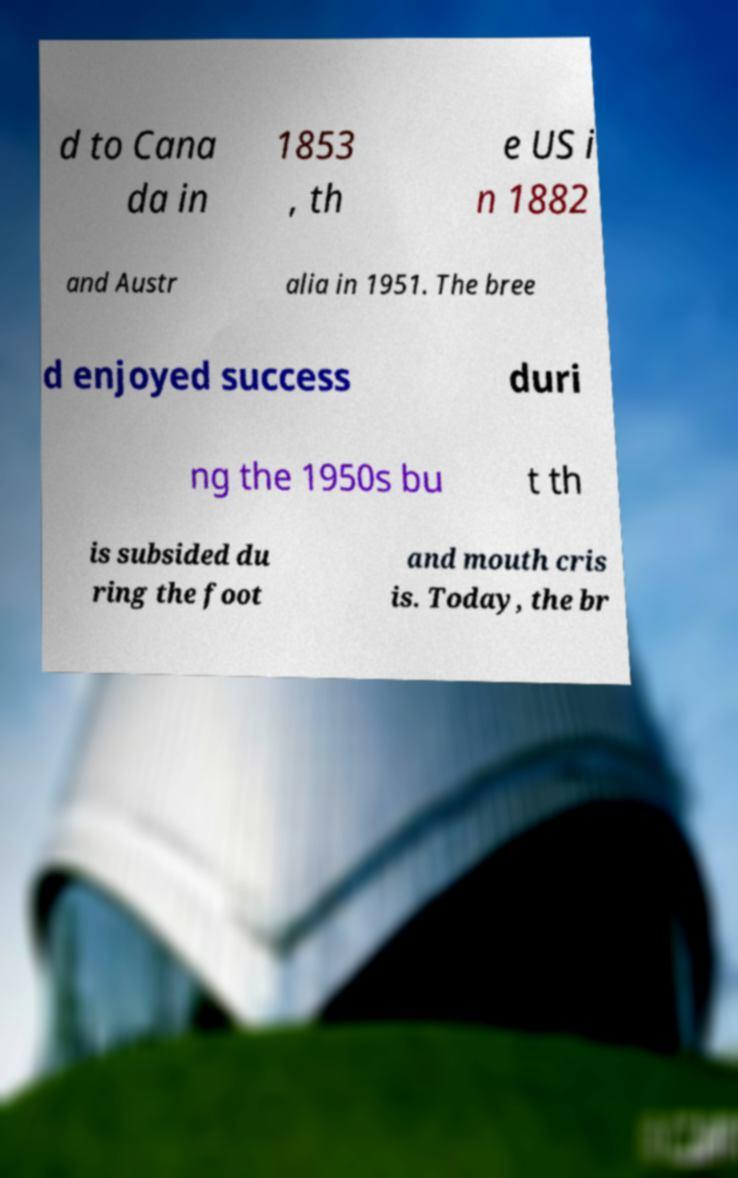Please identify and transcribe the text found in this image. d to Cana da in 1853 , th e US i n 1882 and Austr alia in 1951. The bree d enjoyed success duri ng the 1950s bu t th is subsided du ring the foot and mouth cris is. Today, the br 